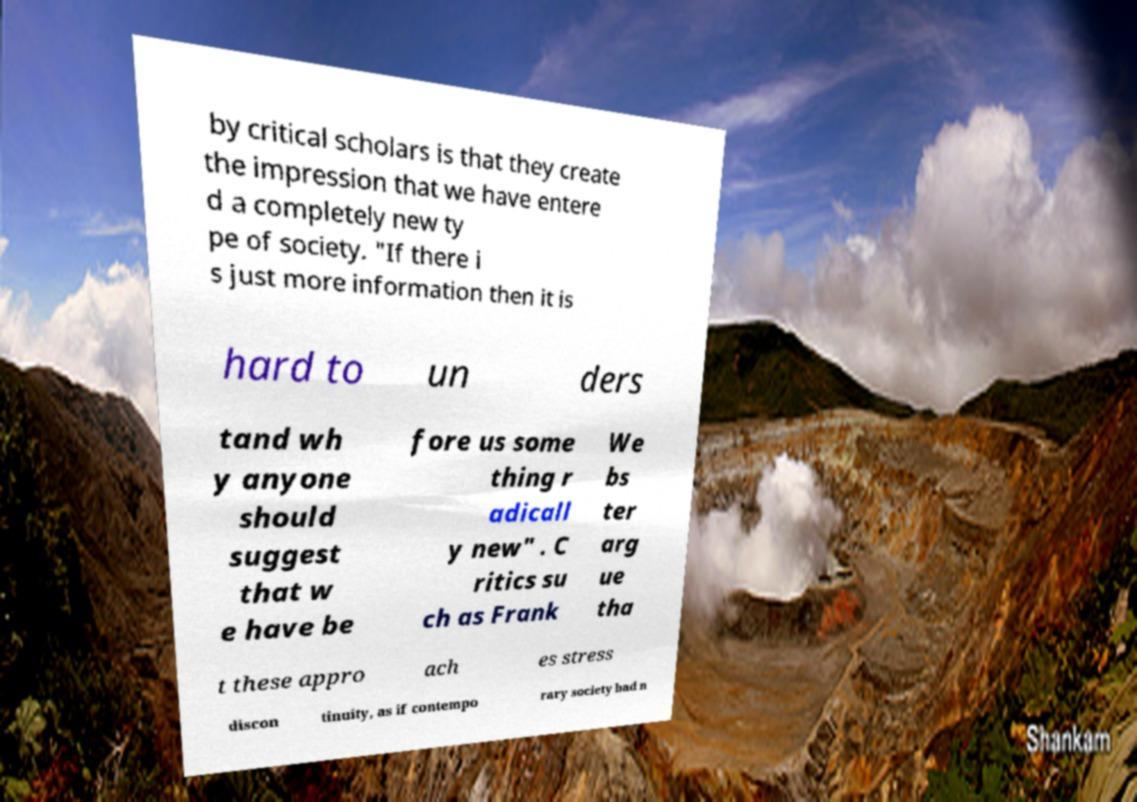I need the written content from this picture converted into text. Can you do that? by critical scholars is that they create the impression that we have entere d a completely new ty pe of society. "If there i s just more information then it is hard to un ders tand wh y anyone should suggest that w e have be fore us some thing r adicall y new" . C ritics su ch as Frank We bs ter arg ue tha t these appro ach es stress discon tinuity, as if contempo rary society had n 